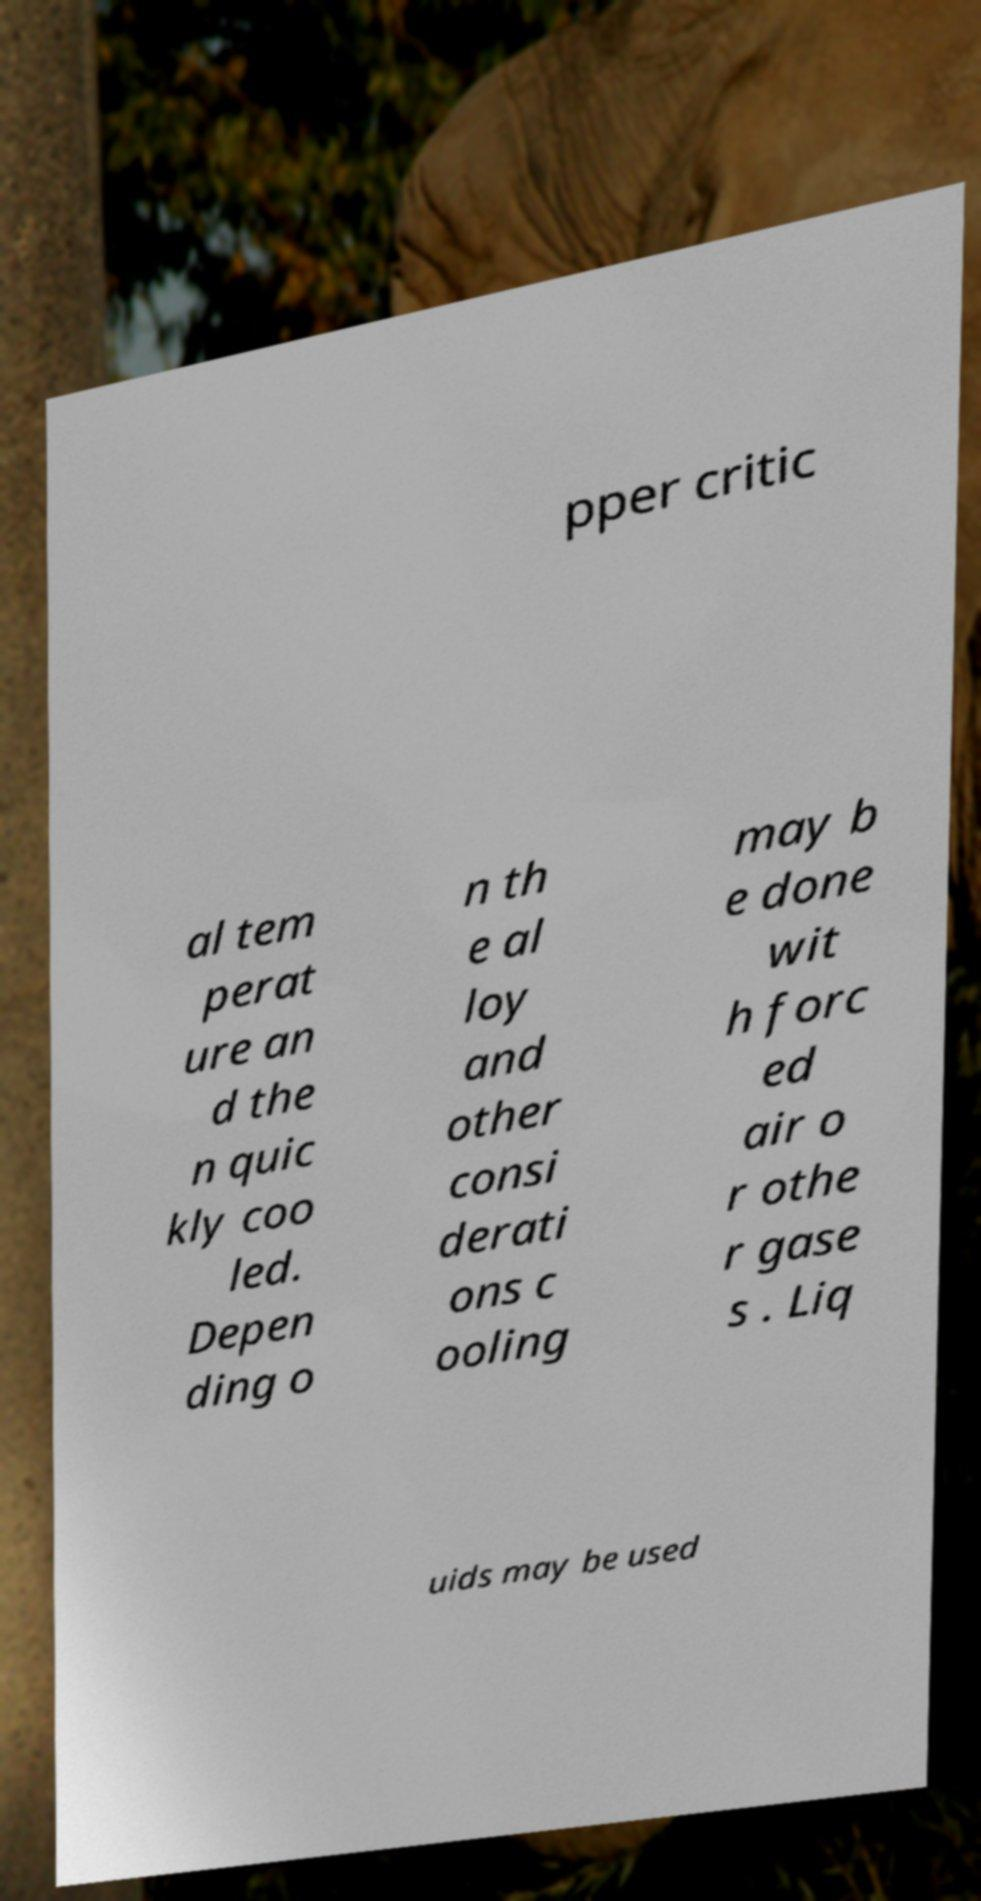Can you read and provide the text displayed in the image?This photo seems to have some interesting text. Can you extract and type it out for me? pper critic al tem perat ure an d the n quic kly coo led. Depen ding o n th e al loy and other consi derati ons c ooling may b e done wit h forc ed air o r othe r gase s . Liq uids may be used 